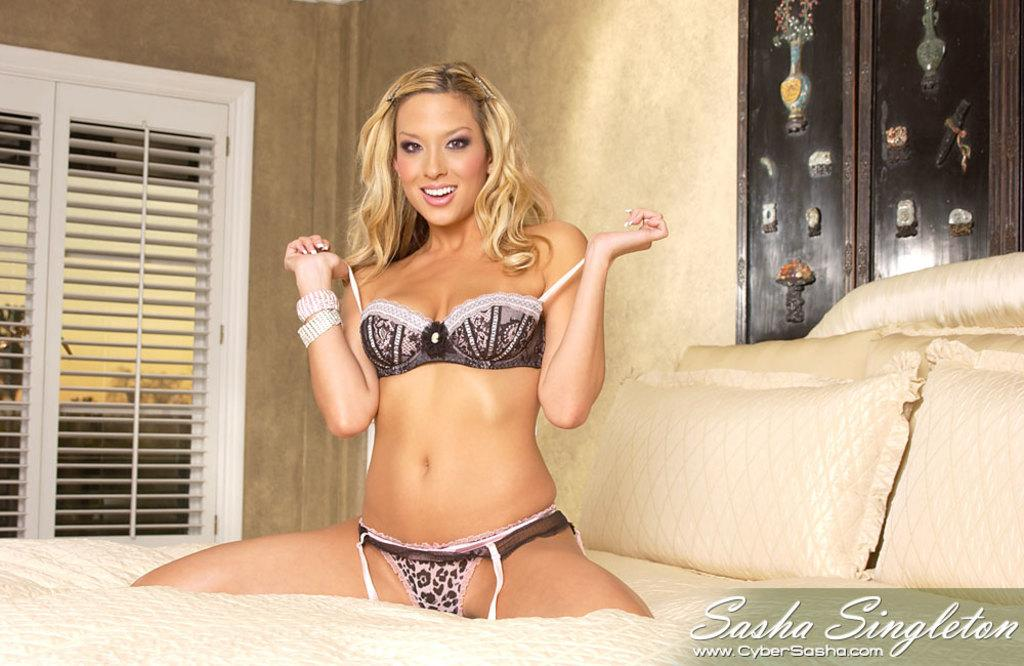What is the person in the image doing? There is a person on the bed in the image. What can be seen on the bed besides the person? There are pillows on the bed. What is visible on the wall in the image? There is a wall in the image. What architectural feature is present in the image? There is a window in the image. What is located towards the right side of the image? There is text towards the right of the image. How many bikes are parked near the window in the image? There are no bikes present in the image. What type of rhythm can be heard coming from the text in the image? There is no sound or rhythm associated with the text in the image. 